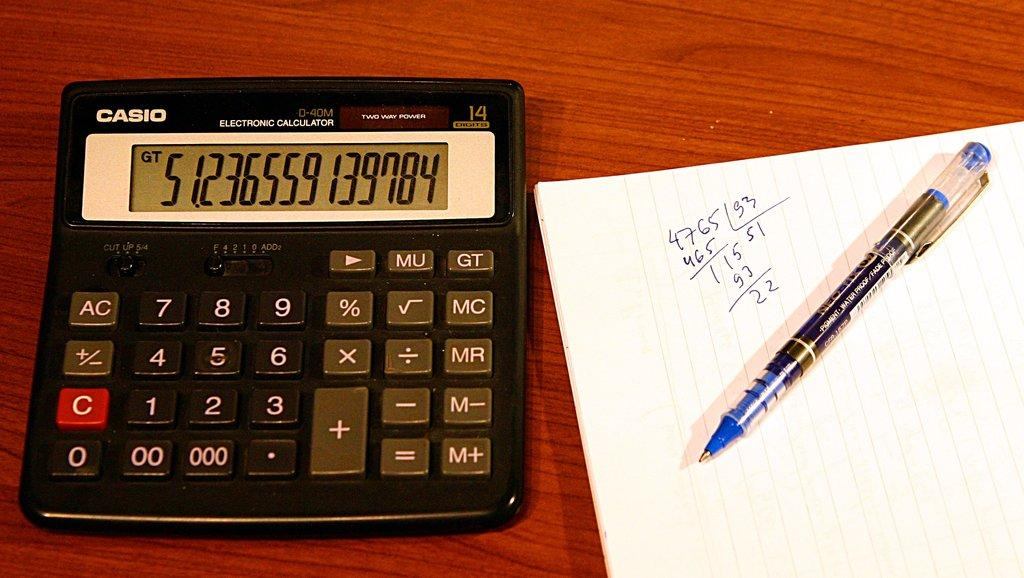<image>
Summarize the visual content of the image. A Casio brand calculator next to a pen and paper. 